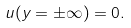Convert formula to latex. <formula><loc_0><loc_0><loc_500><loc_500>u ( y = \pm \infty ) = 0 .</formula> 